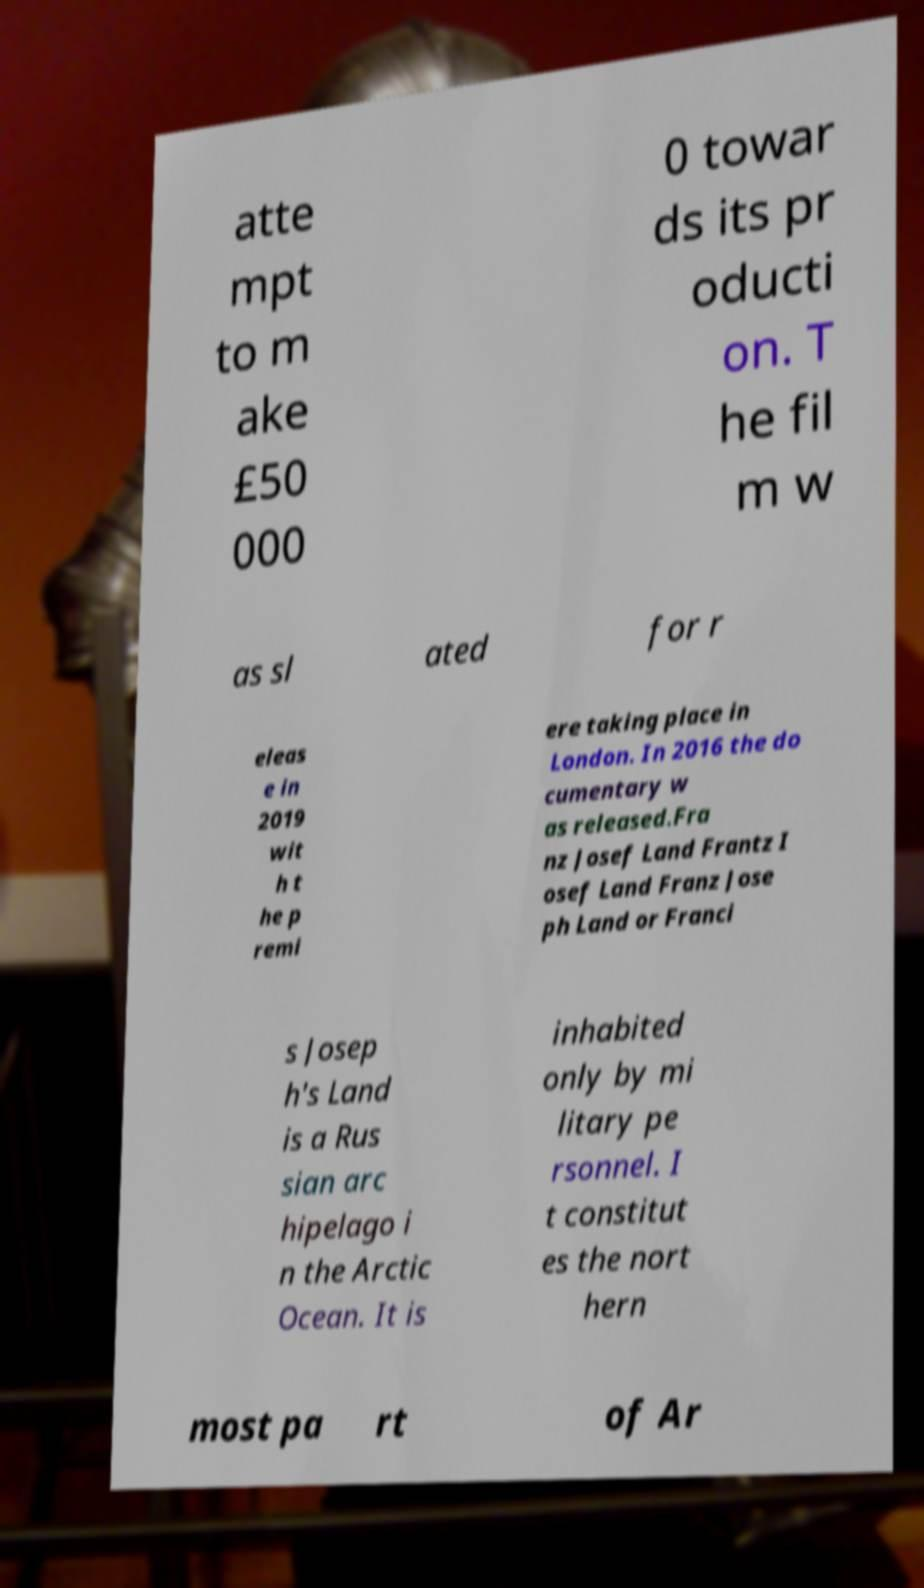Could you assist in decoding the text presented in this image and type it out clearly? atte mpt to m ake £50 000 0 towar ds its pr oducti on. T he fil m w as sl ated for r eleas e in 2019 wit h t he p remi ere taking place in London. In 2016 the do cumentary w as released.Fra nz Josef Land Frantz I osef Land Franz Jose ph Land or Franci s Josep h's Land is a Rus sian arc hipelago i n the Arctic Ocean. It is inhabited only by mi litary pe rsonnel. I t constitut es the nort hern most pa rt of Ar 